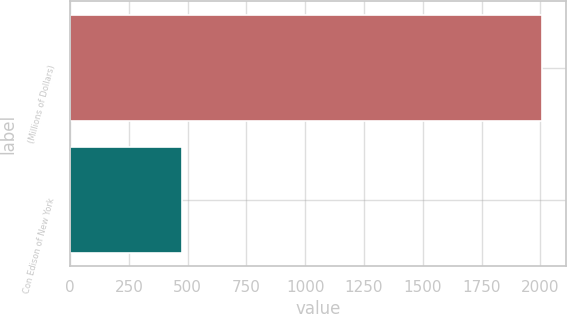<chart> <loc_0><loc_0><loc_500><loc_500><bar_chart><fcel>(Millions of Dollars)<fcel>Con Edison of New York<nl><fcel>2008<fcel>474<nl></chart> 